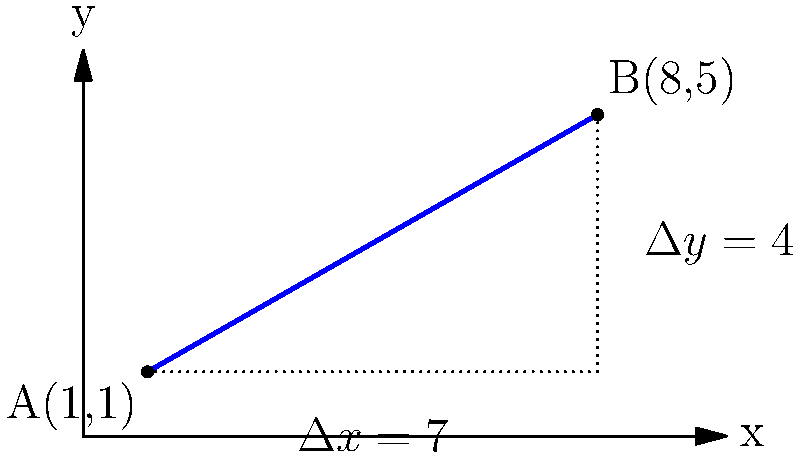For your annual Hocus Pocus-themed Halloween party, you've set up a broomstick trajectory game. The broomstick's path is represented by a straight line from point A(1,1) to point B(8,5) on a coordinate grid. Calculate the slope of the broomstick's trajectory. To find the slope of the broomstick's trajectory, we'll use the slope formula:

$$m = \frac{\Delta y}{\Delta x} = \frac{y_2 - y_1}{x_2 - x_1}$$

Where $(x_1, y_1)$ is the starting point A, and $(x_2, y_2)$ is the ending point B.

Step 1: Identify the coordinates
A: $(x_1, y_1) = (1, 1)$
B: $(x_2, y_2) = (8, 5)$

Step 2: Calculate $\Delta x$ and $\Delta y$
$\Delta x = x_2 - x_1 = 8 - 1 = 7$
$\Delta y = y_2 - y_1 = 5 - 1 = 4$

Step 3: Apply the slope formula
$$m = \frac{\Delta y}{\Delta x} = \frac{4}{7}$$

Step 4: Simplify the fraction (if needed)
The fraction $\frac{4}{7}$ is already in its simplest form.

Therefore, the slope of the broomstick's trajectory is $\frac{4}{7}$.
Answer: $\frac{4}{7}$ 